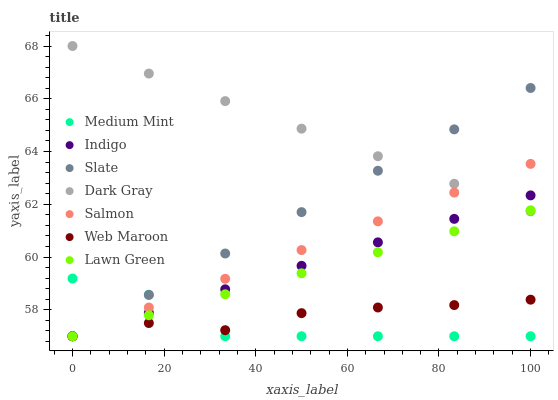Does Medium Mint have the minimum area under the curve?
Answer yes or no. Yes. Does Dark Gray have the maximum area under the curve?
Answer yes or no. Yes. Does Lawn Green have the minimum area under the curve?
Answer yes or no. No. Does Lawn Green have the maximum area under the curve?
Answer yes or no. No. Is Slate the smoothest?
Answer yes or no. Yes. Is Medium Mint the roughest?
Answer yes or no. Yes. Is Lawn Green the smoothest?
Answer yes or no. No. Is Lawn Green the roughest?
Answer yes or no. No. Does Medium Mint have the lowest value?
Answer yes or no. Yes. Does Dark Gray have the lowest value?
Answer yes or no. No. Does Dark Gray have the highest value?
Answer yes or no. Yes. Does Lawn Green have the highest value?
Answer yes or no. No. Is Web Maroon less than Dark Gray?
Answer yes or no. Yes. Is Dark Gray greater than Web Maroon?
Answer yes or no. Yes. Does Dark Gray intersect Lawn Green?
Answer yes or no. Yes. Is Dark Gray less than Lawn Green?
Answer yes or no. No. Is Dark Gray greater than Lawn Green?
Answer yes or no. No. Does Web Maroon intersect Dark Gray?
Answer yes or no. No. 